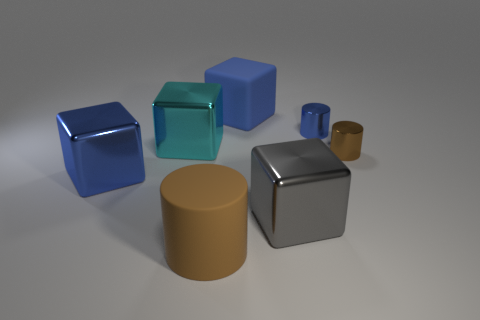What shape is the other large thing that is the same material as the large brown object?
Give a very brief answer. Cube. Are there any other things that are the same shape as the big blue metallic thing?
Your answer should be very brief. Yes. The tiny blue metallic object is what shape?
Your answer should be compact. Cylinder. There is a matte thing that is in front of the blue metallic block; is its shape the same as the small brown object?
Provide a short and direct response. Yes. Is the number of rubber cylinders behind the large cyan metal object greater than the number of gray cubes that are behind the blue rubber block?
Make the answer very short. No. How many other objects are the same size as the rubber cube?
Give a very brief answer. 4. There is a big cyan metallic object; does it have the same shape as the blue metallic object in front of the brown shiny object?
Give a very brief answer. Yes. How many metal things are either large things or big cyan spheres?
Your response must be concise. 3. Are there any matte things of the same color as the rubber cylinder?
Provide a succinct answer. No. Are any gray rubber objects visible?
Make the answer very short. No. 